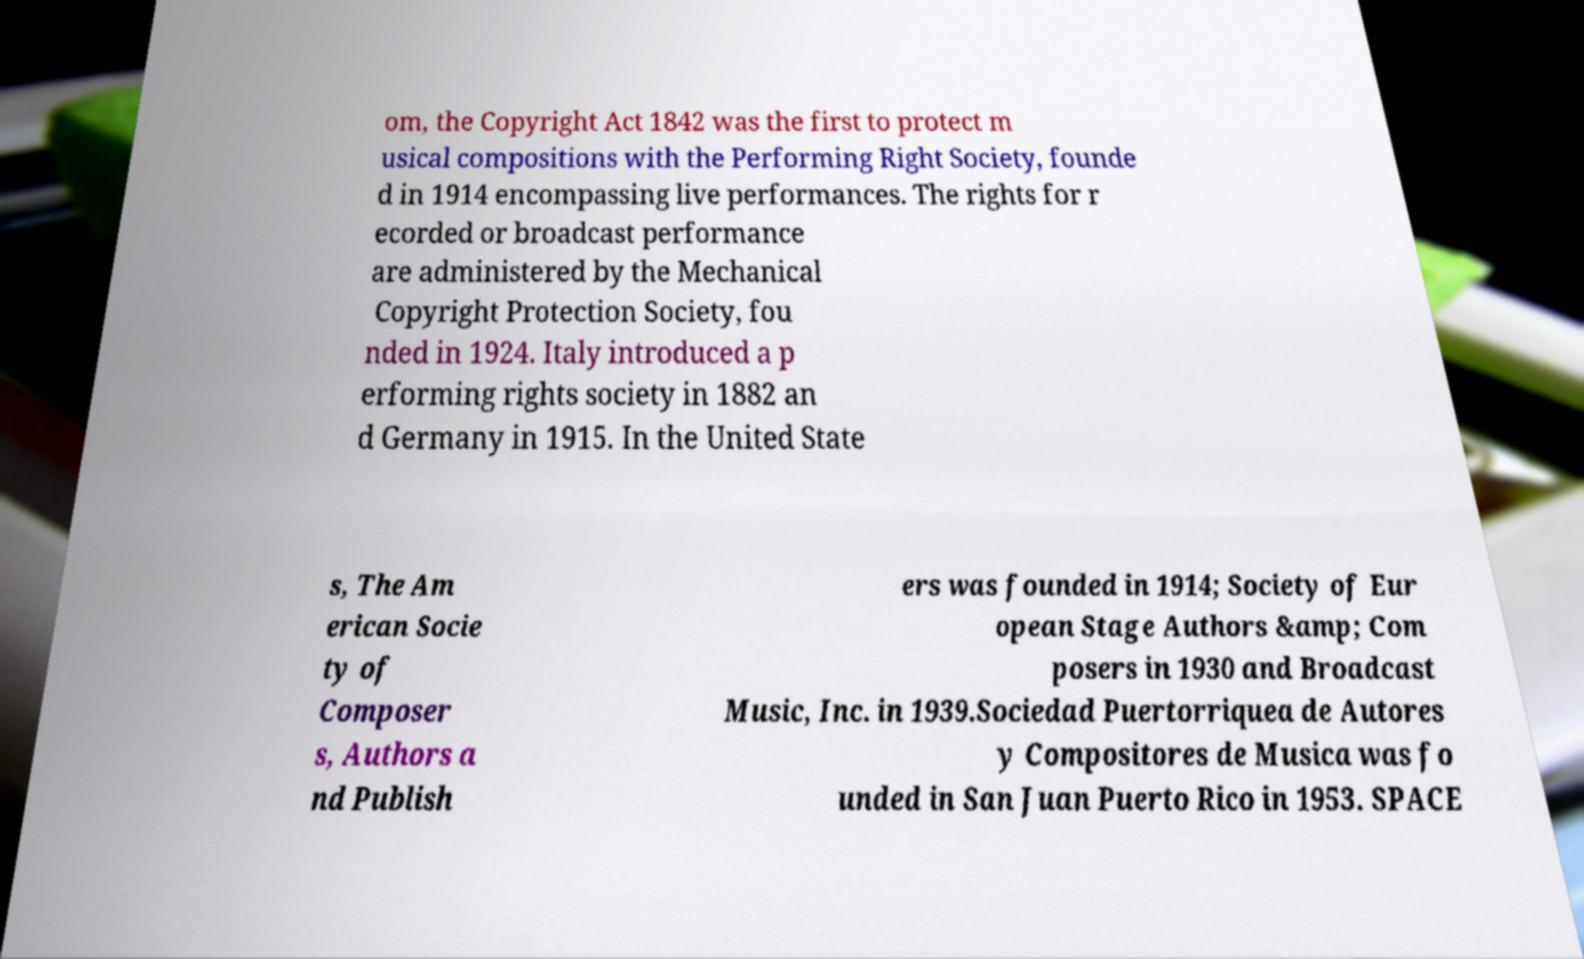Can you accurately transcribe the text from the provided image for me? om, the Copyright Act 1842 was the first to protect m usical compositions with the Performing Right Society, founde d in 1914 encompassing live performances. The rights for r ecorded or broadcast performance are administered by the Mechanical Copyright Protection Society, fou nded in 1924. Italy introduced a p erforming rights society in 1882 an d Germany in 1915. In the United State s, The Am erican Socie ty of Composer s, Authors a nd Publish ers was founded in 1914; Society of Eur opean Stage Authors &amp; Com posers in 1930 and Broadcast Music, Inc. in 1939.Sociedad Puertorriquea de Autores y Compositores de Musica was fo unded in San Juan Puerto Rico in 1953. SPACE 